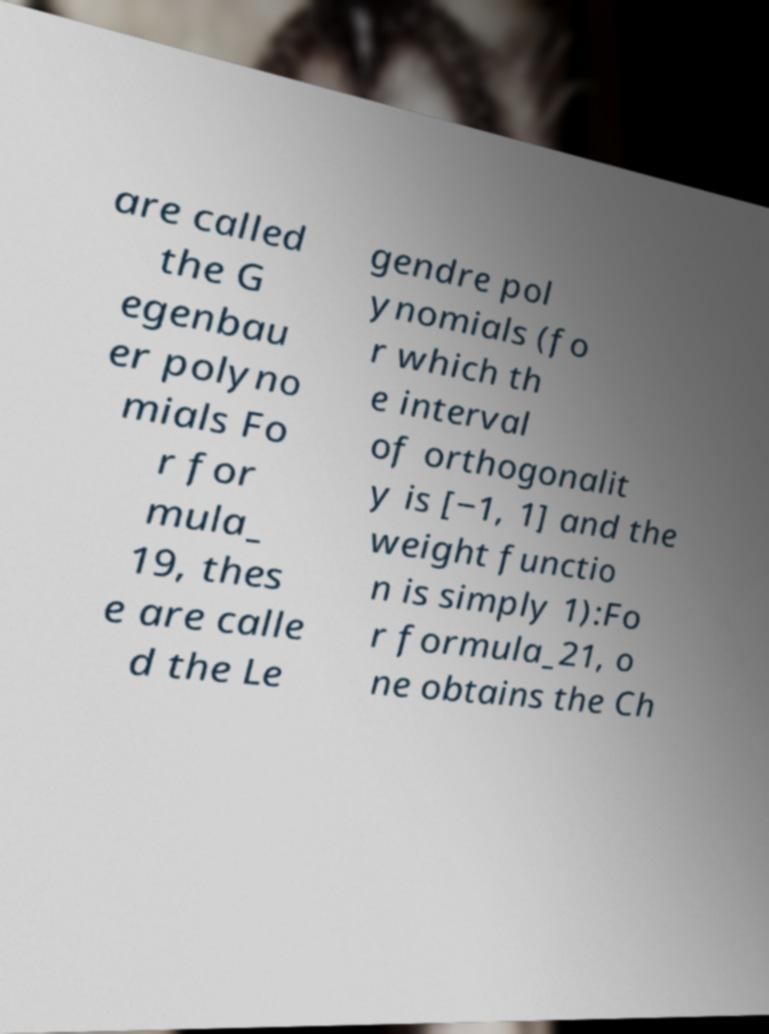Can you read and provide the text displayed in the image?This photo seems to have some interesting text. Can you extract and type it out for me? are called the G egenbau er polyno mials Fo r for mula_ 19, thes e are calle d the Le gendre pol ynomials (fo r which th e interval of orthogonalit y is [−1, 1] and the weight functio n is simply 1):Fo r formula_21, o ne obtains the Ch 